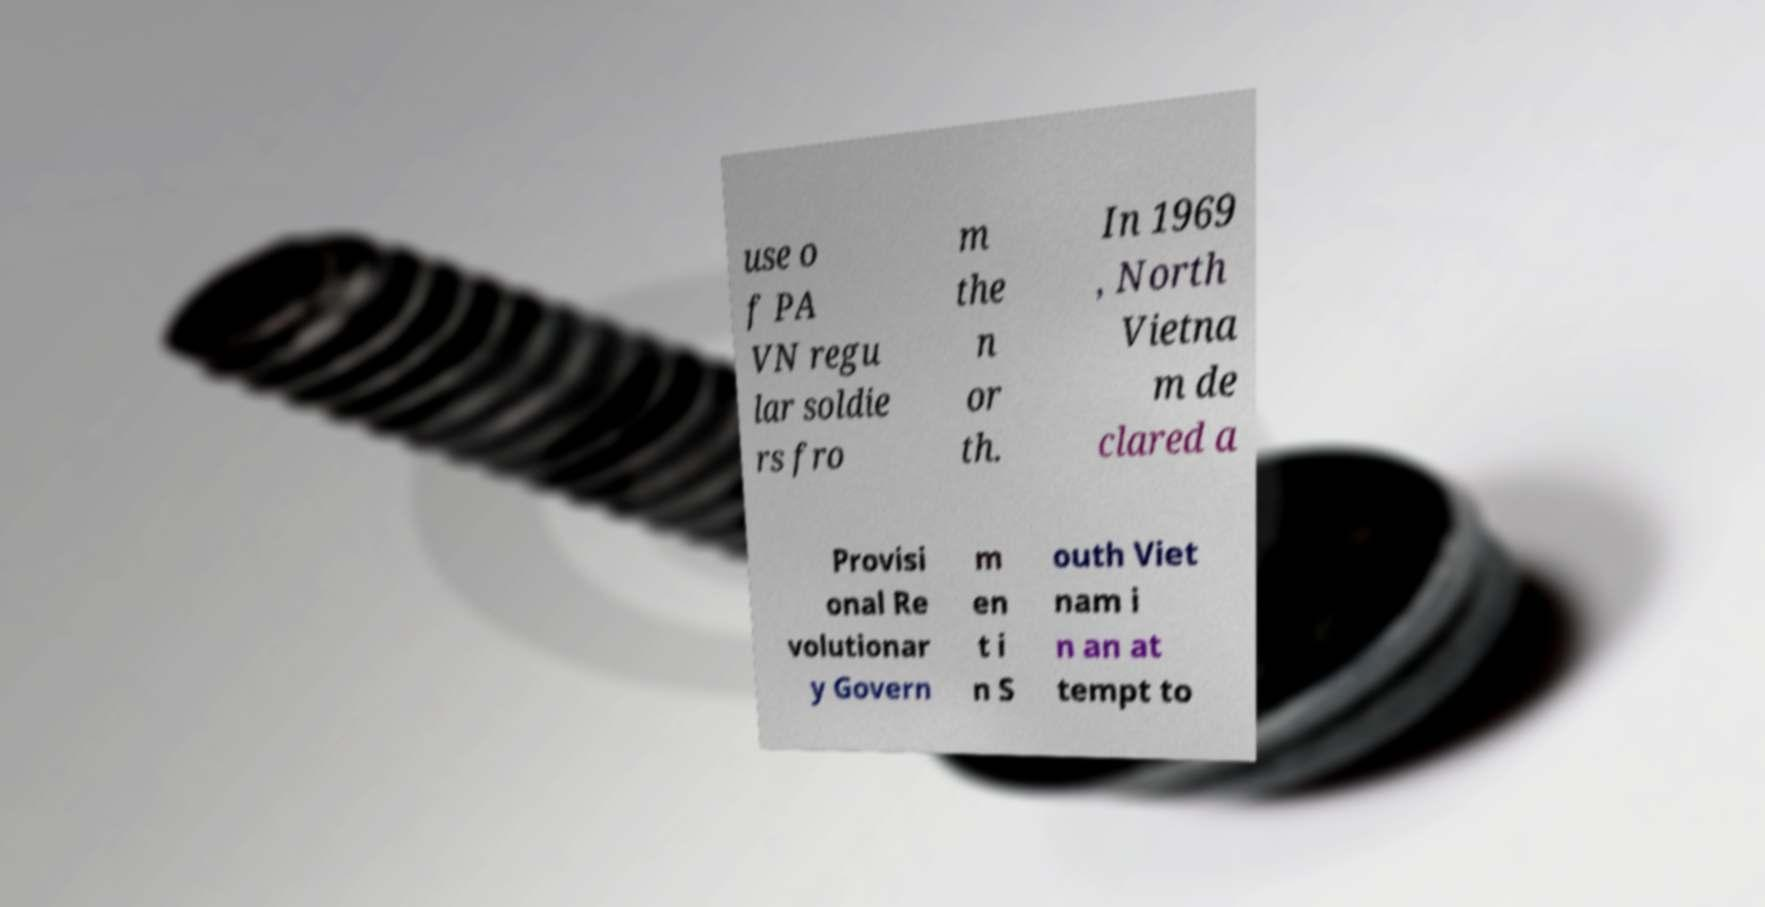Please read and relay the text visible in this image. What does it say? use o f PA VN regu lar soldie rs fro m the n or th. In 1969 , North Vietna m de clared a Provisi onal Re volutionar y Govern m en t i n S outh Viet nam i n an at tempt to 